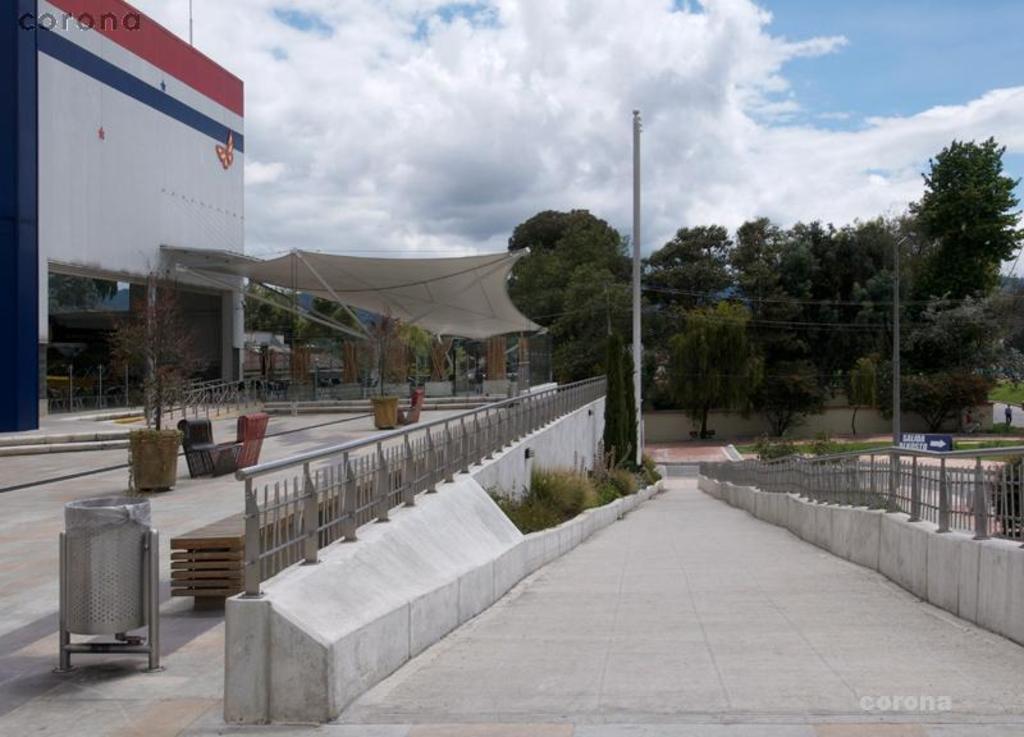In one or two sentences, can you explain what this image depicts? In this picture there is a concrete ramp with iron railing on both the sides. Behind there is a white color canopy shed. On the left side there is a big white wall. In the background there are many trees and in the front bottom side, wooden rafters and steel dustbin placed on the ground. 